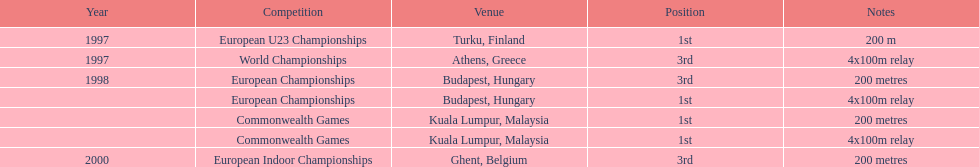During the 2000 european indoor championships, what was the distance of the sprint competition? 200 metres. 